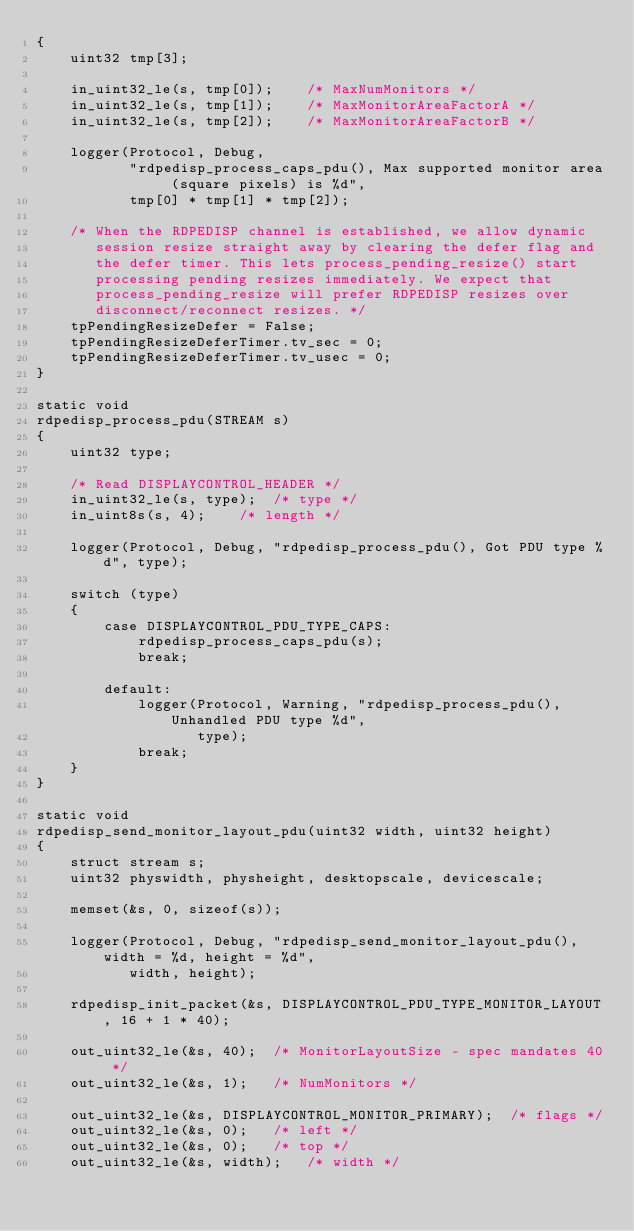<code> <loc_0><loc_0><loc_500><loc_500><_C_>{
	uint32 tmp[3];

	in_uint32_le(s, tmp[0]);	/* MaxNumMonitors */
	in_uint32_le(s, tmp[1]);	/* MaxMonitorAreaFactorA */
	in_uint32_le(s, tmp[2]);	/* MaxMonitorAreaFactorB */

	logger(Protocol, Debug,
	       "rdpedisp_process_caps_pdu(), Max supported monitor area (square pixels) is %d",
	       tmp[0] * tmp[1] * tmp[2]);

	/* When the RDPEDISP channel is established, we allow dynamic
	   session resize straight away by clearing the defer flag and
	   the defer timer. This lets process_pending_resize() start
	   processing pending resizes immediately. We expect that
	   process_pending_resize will prefer RDPEDISP resizes over
	   disconnect/reconnect resizes. */
	tpPendingResizeDefer = False;
	tpPendingResizeDeferTimer.tv_sec = 0;
	tpPendingResizeDeferTimer.tv_usec = 0;
}

static void
rdpedisp_process_pdu(STREAM s)
{
	uint32 type;

	/* Read DISPLAYCONTROL_HEADER */
	in_uint32_le(s, type);	/* type */
	in_uint8s(s, 4);	/* length */

	logger(Protocol, Debug, "rdpedisp_process_pdu(), Got PDU type %d", type);

	switch (type)
	{
		case DISPLAYCONTROL_PDU_TYPE_CAPS:
			rdpedisp_process_caps_pdu(s);
			break;

		default:
			logger(Protocol, Warning, "rdpedisp_process_pdu(), Unhandled PDU type %d",
			       type);
			break;
	}
}

static void
rdpedisp_send_monitor_layout_pdu(uint32 width, uint32 height)
{
	struct stream s;
	uint32 physwidth, physheight, desktopscale, devicescale;

	memset(&s, 0, sizeof(s));

	logger(Protocol, Debug, "rdpedisp_send_monitor_layout_pdu(), width = %d, height = %d",
	       width, height);

	rdpedisp_init_packet(&s, DISPLAYCONTROL_PDU_TYPE_MONITOR_LAYOUT, 16 + 1 * 40);

	out_uint32_le(&s, 40);	/* MonitorLayoutSize - spec mandates 40 */
	out_uint32_le(&s, 1);	/* NumMonitors */

	out_uint32_le(&s, DISPLAYCONTROL_MONITOR_PRIMARY);	/* flags */
	out_uint32_le(&s, 0);	/* left */
	out_uint32_le(&s, 0);	/* top */
	out_uint32_le(&s, width);	/* width */</code> 